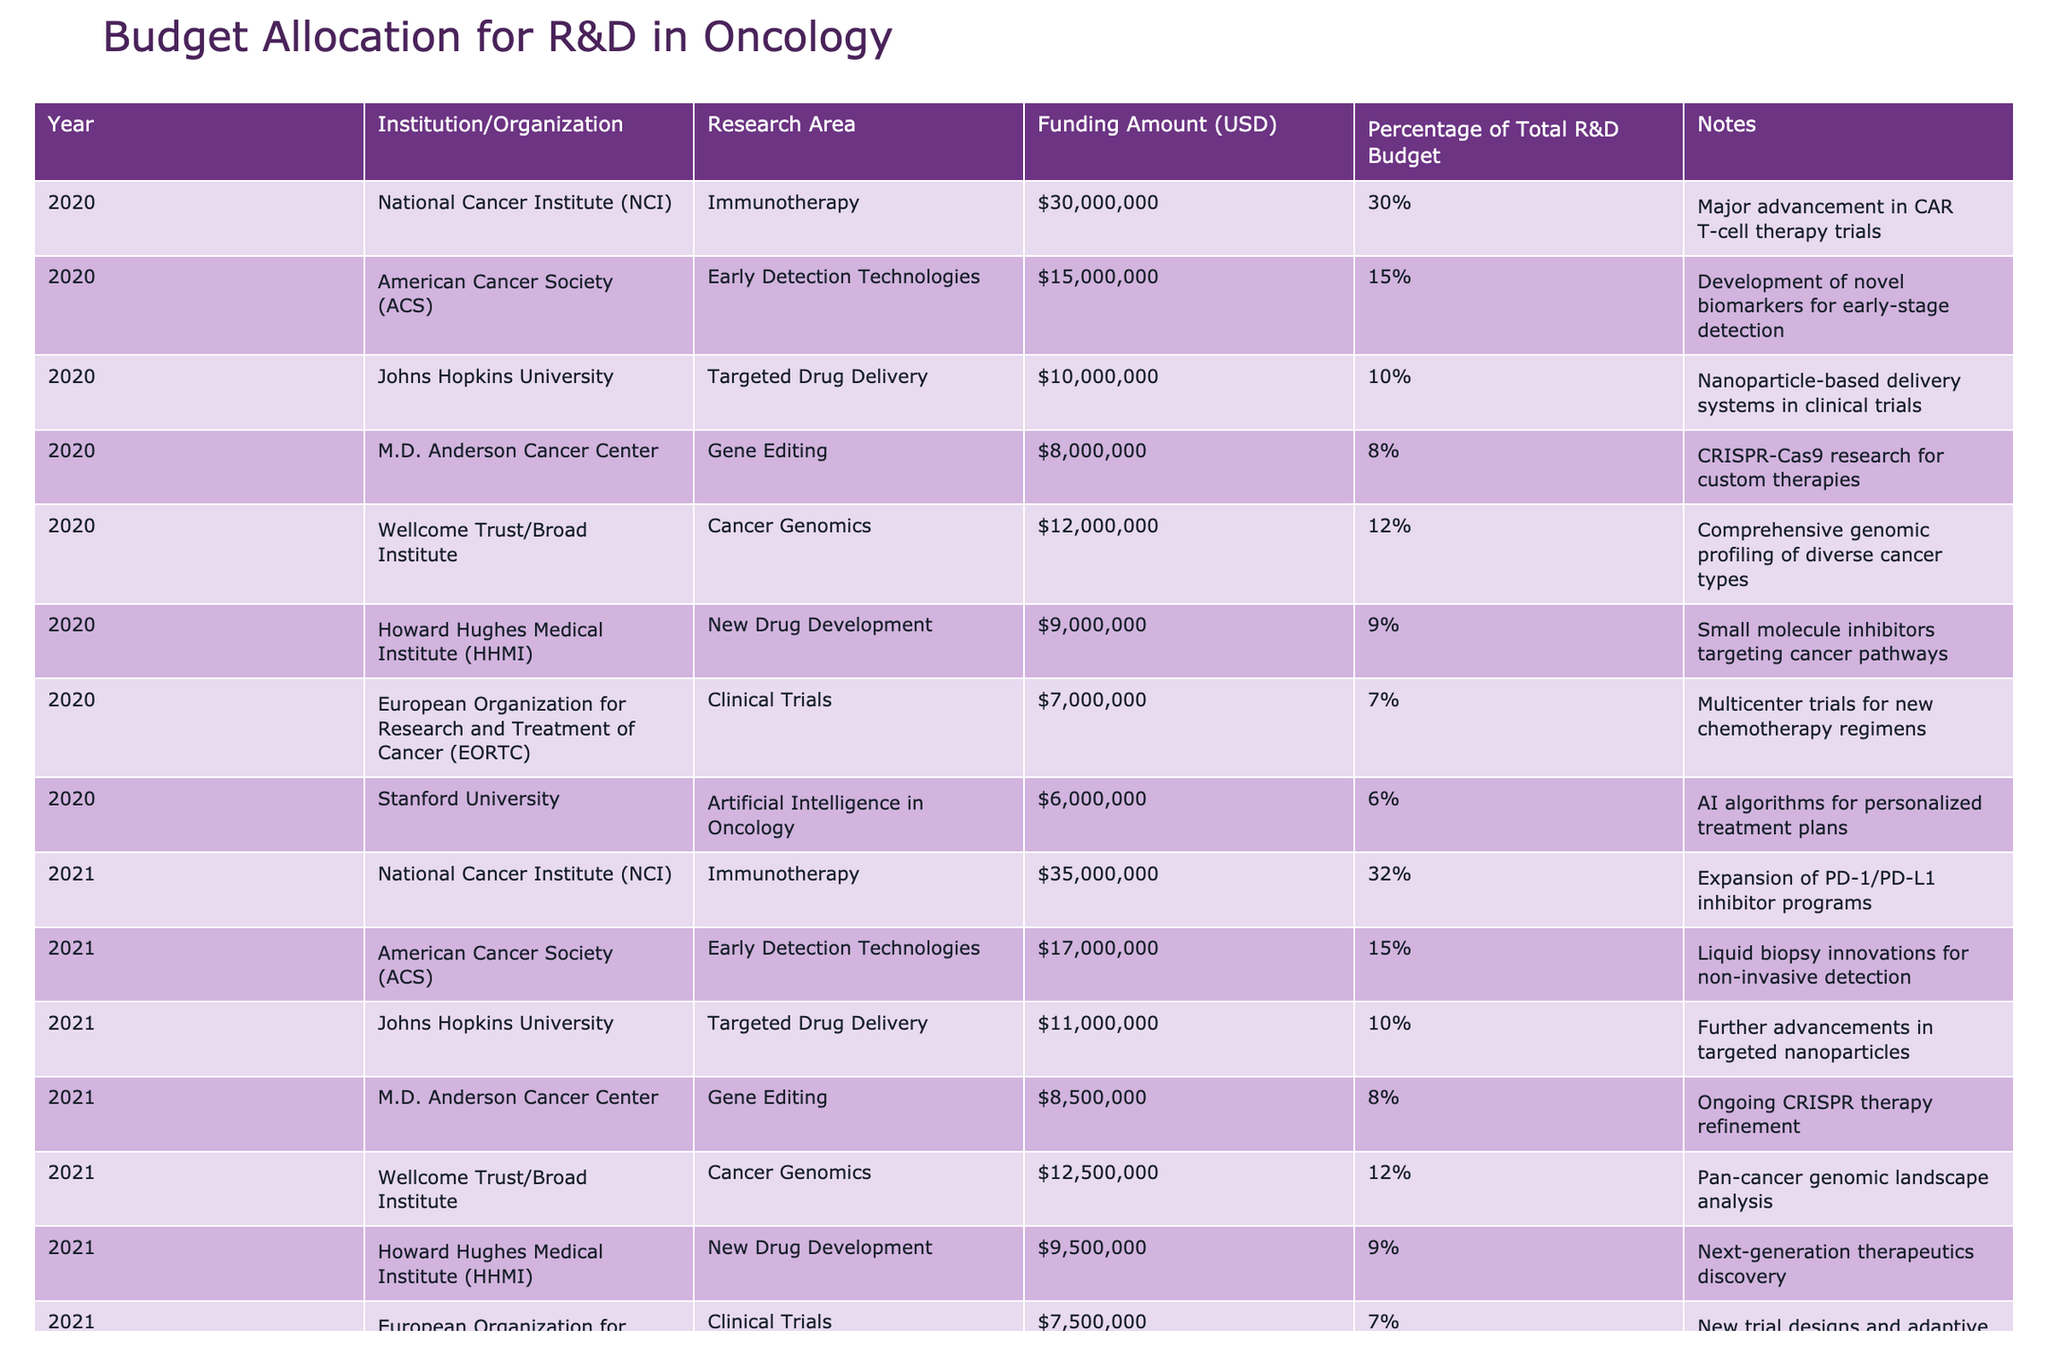What was the total funding amount allocated for immunotherapy in 2020? In 2020, the funding amount for immunotherapy by the National Cancer Institute was $30,000,000. There were no other entries for immunotherapy in 2020, so the total remains $30,000,000.
Answer: 30,000,000 Which institution received the highest funding for cancer genomics in 2022? In 2022, the Wellcome Trust/Broad Institute received $13,000,000 for cancer genomics, making it the highest among the institutions listed for this research area in that year.
Answer: Wellcome Trust/Broad Institute What percentage of the total R&D budget was allocated to clinical trials by the National Cancer Institute in 2020? The National Cancer Institute allocated 7% of the total R&D budget to clinical trials in 2020, which is specified in the table.
Answer: 7% What is the average funding amount for early detection technologies from 2020 to 2022? The funding amounts for early detection technologies are $15,000,000 (2020), $17,000,000 (2021), and $18,000,000 (2022). The total funding is $50,000,000 across three years. Dividing by 3 gives an average of $16,666,667.
Answer: 16,666,667 Did the funding for gene editing increase from 2020 to 2022? In 2020, the funding amount for gene editing was $8,000,000 and it increased to $9,000,000 in 2022. Since $9,000,000 is greater than $8,000,000, the funding did indeed increase.
Answer: Yes What was the overall percentage of the total R&D budget allocated to targeted drug delivery in 2021? The funding for targeted drug delivery in 2021 was $11,000,000, which accounted for 10% of the total R&D budget that year as specified in the table.
Answer: 10% Which year had the highest total funding amount for cancer genomics, and what was that amount? In 2022, the funding amount for cancer genomics was $13,000,000, which is higher than the 2020 amount of $12,000,000 and the 2021 amount of $12,500,000. Thus, 2022 had the highest total funding for this area.
Answer: 13,000,000 Calculate the total funding amount for all institutions combined in 2021. Summing the amounts allocated in 2021: $35,000,000 (NCI) + $17,000,000 (ACS) + $11,000,000 (Johns Hopkins) + $8,500,000 (M.D. Anderson) + $12,500,000 (Wellcome Trust) + $9,500,000 (HHMI) + $7,500,000 (EORTC) + $6,500,000 (Stanford) gives a total of $107,000,000.
Answer: 107,000,000 